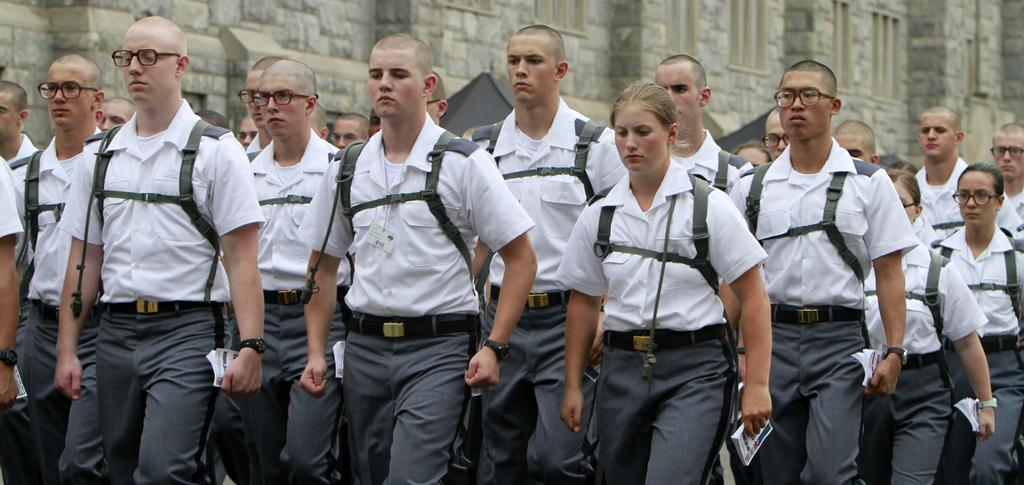How many people are in the image? There is a group of people in the image. What are the people doing in the image? The people are standing on the ground. What are the people wearing in the image? The people are wearing white shirts. What are the people holding in the image? The people are holding books in their hands. What can be seen in the background of the image? There is a wall in the background of the image. What type of tin can be seen on the ground in the image? There is no tin present in the image; the people are standing on the ground. How many crates are visible in the image? There are no crates present in the image. 